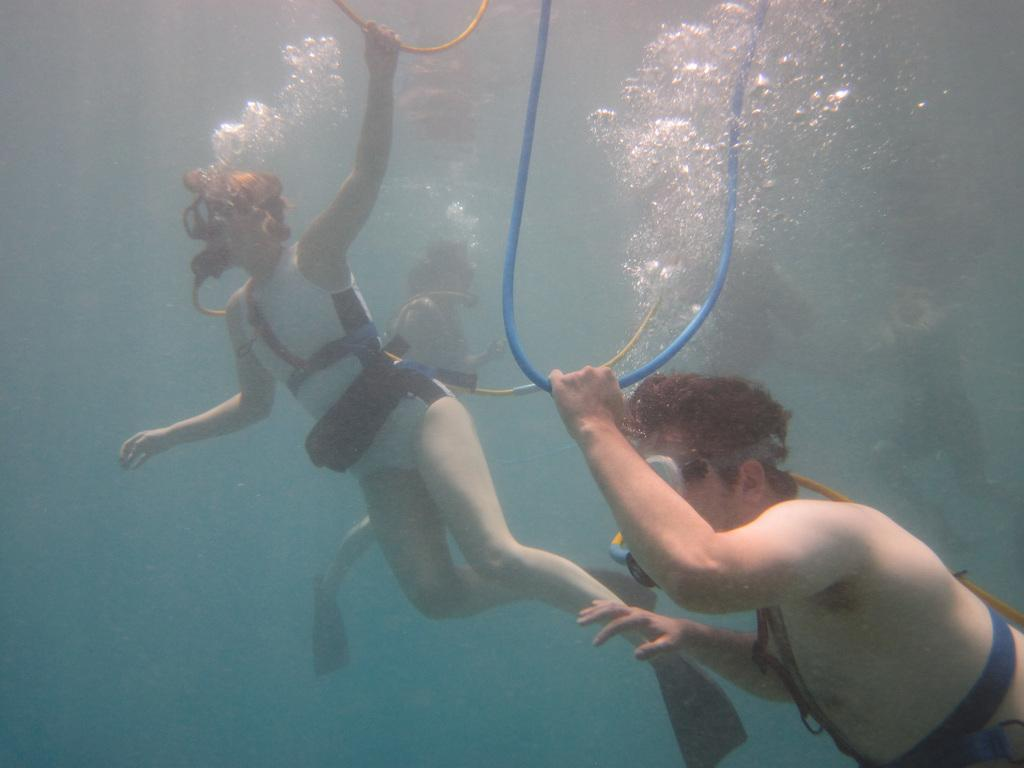Who is present in the image? There are people in the image. What activity are the people engaged in? The people are doing scuba diving. Where does the scuba diving take place? The scuba diving takes place in the water. What type of nest can be seen in the image? There is no nest present in the image; it features people doing scuba diving in the water. 